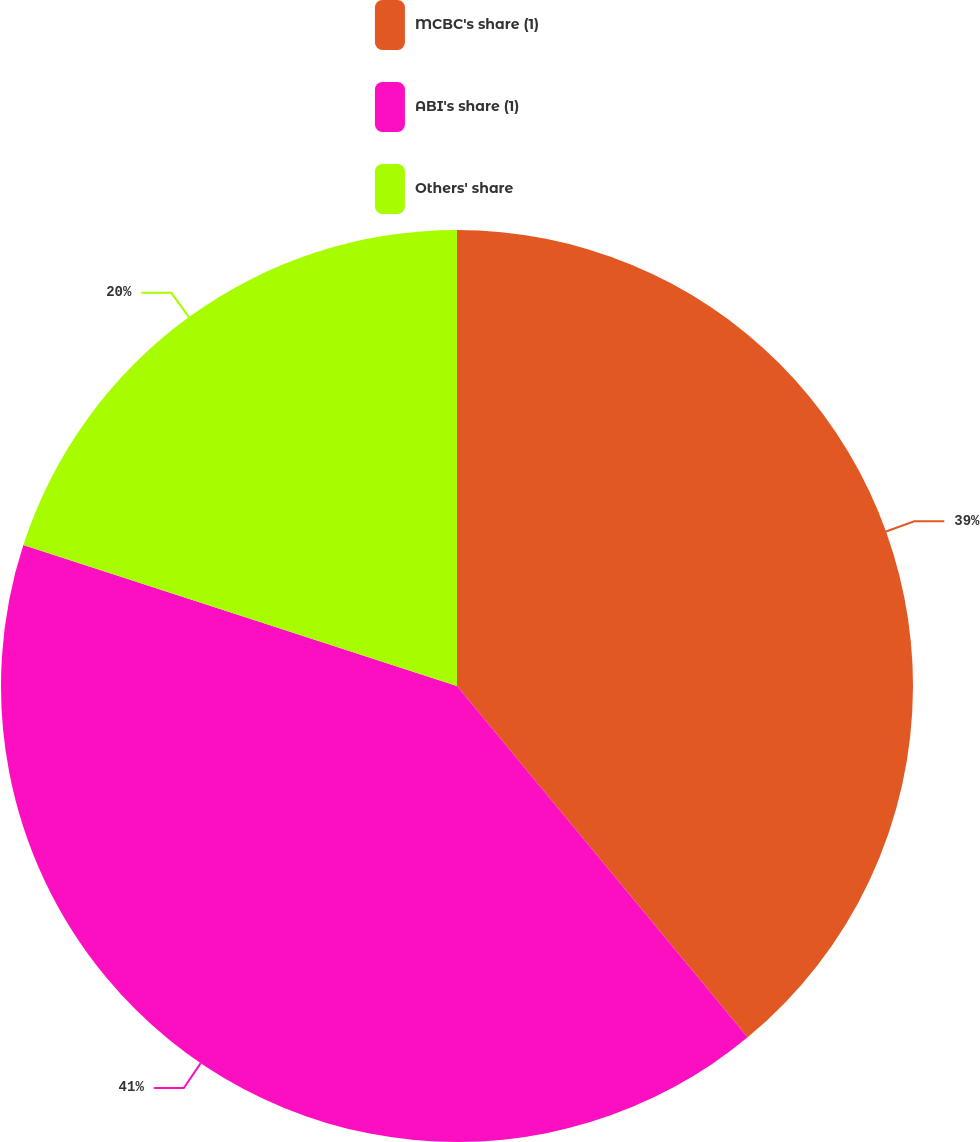Convert chart to OTSL. <chart><loc_0><loc_0><loc_500><loc_500><pie_chart><fcel>MCBC's share (1)<fcel>ABI's share (1)<fcel>Others' share<nl><fcel>39.0%<fcel>41.0%<fcel>20.0%<nl></chart> 